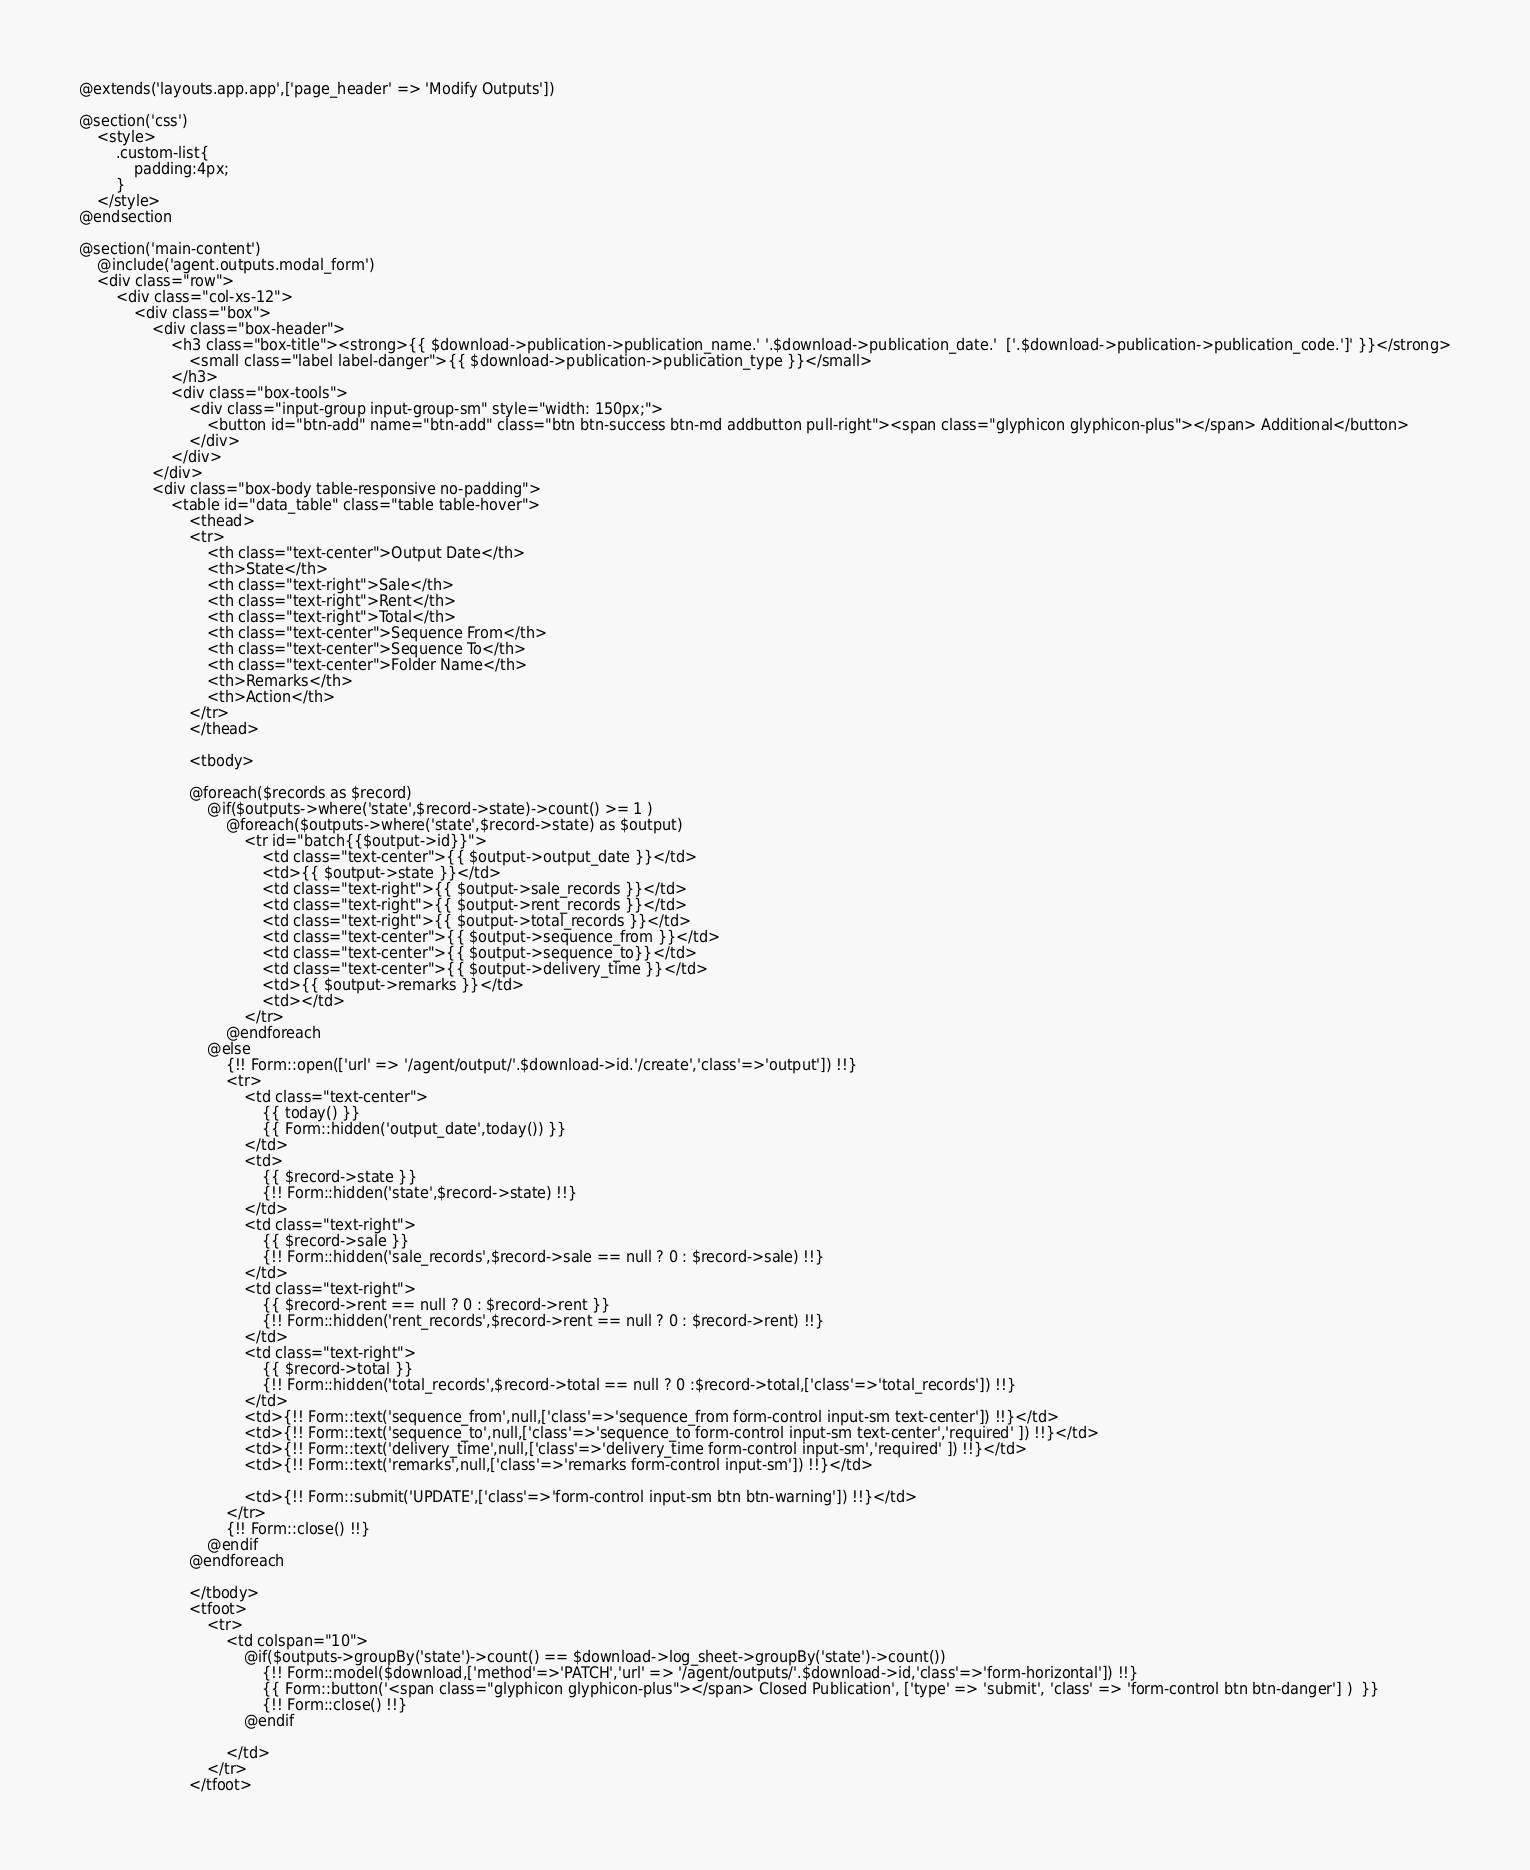Convert code to text. <code><loc_0><loc_0><loc_500><loc_500><_PHP_>@extends('layouts.app.app',['page_header' => 'Modify Outputs'])

@section('css')
    <style>
        .custom-list{
            padding:4px;
        }
    </style>
@endsection

@section('main-content')
    @include('agent.outputs.modal_form')
    <div class="row">
        <div class="col-xs-12">
            <div class="box">
                <div class="box-header">
                    <h3 class="box-title"><strong>{{ $download->publication->publication_name.' '.$download->publication_date.'  ['.$download->publication->publication_code.']' }}</strong>
                        <small class="label label-danger">{{ $download->publication->publication_type }}</small>
                    </h3>
                    <div class="box-tools">
                        <div class="input-group input-group-sm" style="width: 150px;">
                            <button id="btn-add" name="btn-add" class="btn btn-success btn-md addbutton pull-right"><span class="glyphicon glyphicon-plus"></span> Additional</button>
                        </div>
                    </div>
                </div>
                <div class="box-body table-responsive no-padding">
                    <table id="data_table" class="table table-hover">
                        <thead>
                        <tr>
                            <th class="text-center">Output Date</th>
                            <th>State</th>
                            <th class="text-right">Sale</th>
                            <th class="text-right">Rent</th>
                            <th class="text-right">Total</th>
                            <th class="text-center">Sequence From</th>
                            <th class="text-center">Sequence To</th>
                            <th class="text-center">Folder Name</th>
                            <th>Remarks</th>
                            <th>Action</th>
                        </tr>
                        </thead>

                        <tbody>

                        @foreach($records as $record)
                            @if($outputs->where('state',$record->state)->count() >= 1 )
                                @foreach($outputs->where('state',$record->state) as $output)
                                    <tr id="batch{{$output->id}}">
                                        <td class="text-center">{{ $output->output_date }}</td>
                                        <td>{{ $output->state }}</td>
                                        <td class="text-right">{{ $output->sale_records }}</td>
                                        <td class="text-right">{{ $output->rent_records }}</td>
                                        <td class="text-right">{{ $output->total_records }}</td>
                                        <td class="text-center">{{ $output->sequence_from }}</td>
                                        <td class="text-center">{{ $output->sequence_to}}</td>
                                        <td class="text-center">{{ $output->delivery_time }}</td>
                                        <td>{{ $output->remarks }}</td>
                                        <td></td>
                                    </tr>
                                @endforeach
                            @else
                                {!! Form::open(['url' => '/agent/output/'.$download->id.'/create','class'=>'output']) !!}
                                <tr>
                                    <td class="text-center">
                                        {{ today() }}
                                        {{ Form::hidden('output_date',today()) }}
                                    </td>
                                    <td>
                                        {{ $record->state }}
                                        {!! Form::hidden('state',$record->state) !!}
                                    </td>
                                    <td class="text-right">
                                        {{ $record->sale }}
                                        {!! Form::hidden('sale_records',$record->sale == null ? 0 : $record->sale) !!}
                                    </td>
                                    <td class="text-right">
                                        {{ $record->rent == null ? 0 : $record->rent }}
                                        {!! Form::hidden('rent_records',$record->rent == null ? 0 : $record->rent) !!}
                                    </td>
                                    <td class="text-right">
                                        {{ $record->total }}
                                        {!! Form::hidden('total_records',$record->total == null ? 0 :$record->total,['class'=>'total_records']) !!}
                                    </td>
                                    <td>{!! Form::text('sequence_from',null,['class'=>'sequence_from form-control input-sm text-center']) !!}</td>
                                    <td>{!! Form::text('sequence_to',null,['class'=>'sequence_to form-control input-sm text-center','required' ]) !!}</td>
                                    <td>{!! Form::text('delivery_time',null,['class'=>'delivery_time form-control input-sm','required' ]) !!}</td>
                                    <td>{!! Form::text('remarks',null,['class'=>'remarks form-control input-sm']) !!}</td>

                                    <td>{!! Form::submit('UPDATE',['class'=>'form-control input-sm btn btn-warning']) !!}</td>
                                </tr>
                                {!! Form::close() !!}
                            @endif
                        @endforeach

                        </tbody>
                        <tfoot>
                            <tr>
                                <td colspan="10">
                                    @if($outputs->groupBy('state')->count() == $download->log_sheet->groupBy('state')->count())
                                        {!! Form::model($download,['method'=>'PATCH','url' => '/agent/outputs/'.$download->id,'class'=>'form-horizontal']) !!}
                                        {{ Form::button('<span class="glyphicon glyphicon-plus"></span> Closed Publication', ['type' => 'submit', 'class' => 'form-control btn btn-danger'] )  }}
                                        {!! Form::close() !!}
                                    @endif

                                </td>
                            </tr>
                        </tfoot></code> 